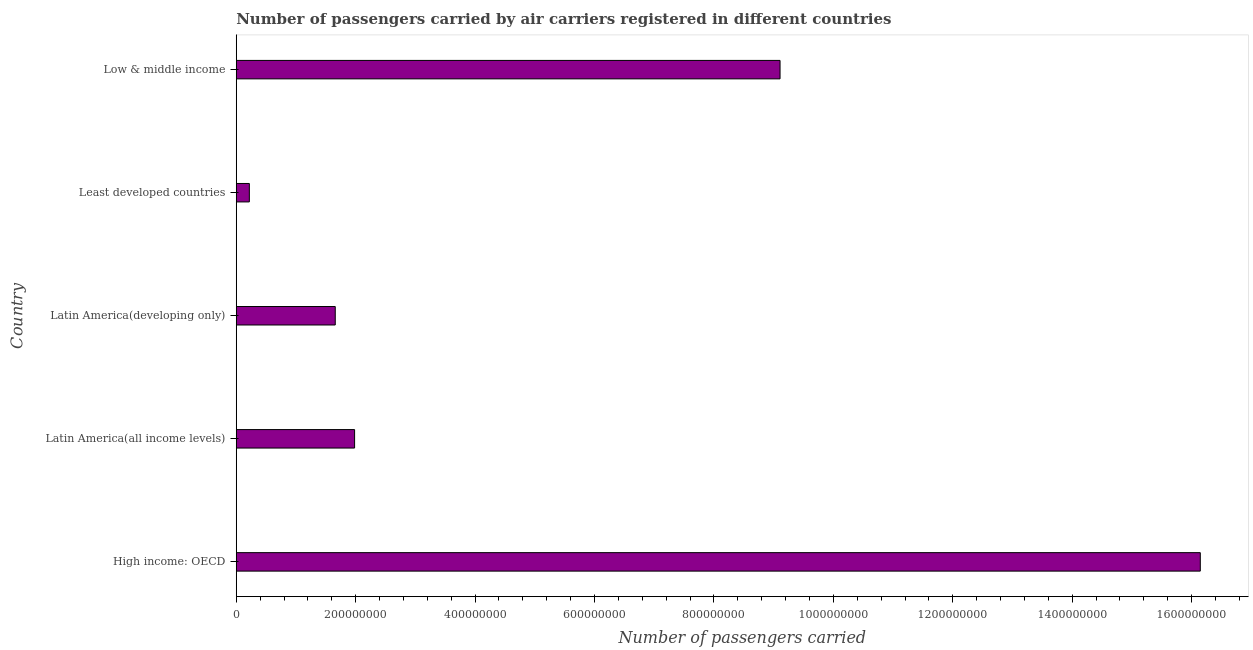Does the graph contain any zero values?
Offer a terse response. No. Does the graph contain grids?
Offer a very short reply. No. What is the title of the graph?
Provide a short and direct response. Number of passengers carried by air carriers registered in different countries. What is the label or title of the X-axis?
Make the answer very short. Number of passengers carried. What is the label or title of the Y-axis?
Offer a very short reply. Country. What is the number of passengers carried in High income: OECD?
Offer a terse response. 1.61e+09. Across all countries, what is the maximum number of passengers carried?
Ensure brevity in your answer.  1.61e+09. Across all countries, what is the minimum number of passengers carried?
Give a very brief answer. 2.19e+07. In which country was the number of passengers carried maximum?
Provide a short and direct response. High income: OECD. In which country was the number of passengers carried minimum?
Provide a short and direct response. Least developed countries. What is the sum of the number of passengers carried?
Ensure brevity in your answer.  2.91e+09. What is the difference between the number of passengers carried in Latin America(all income levels) and Least developed countries?
Give a very brief answer. 1.76e+08. What is the average number of passengers carried per country?
Your answer should be very brief. 5.82e+08. What is the median number of passengers carried?
Make the answer very short. 1.98e+08. In how many countries, is the number of passengers carried greater than 880000000 ?
Offer a very short reply. 2. What is the ratio of the number of passengers carried in Latin America(developing only) to that in Least developed countries?
Your answer should be compact. 7.56. Is the number of passengers carried in Latin America(all income levels) less than that in Low & middle income?
Offer a terse response. Yes. What is the difference between the highest and the second highest number of passengers carried?
Your answer should be compact. 7.04e+08. What is the difference between the highest and the lowest number of passengers carried?
Ensure brevity in your answer.  1.59e+09. How many bars are there?
Ensure brevity in your answer.  5. Are all the bars in the graph horizontal?
Your answer should be very brief. Yes. What is the difference between two consecutive major ticks on the X-axis?
Ensure brevity in your answer.  2.00e+08. Are the values on the major ticks of X-axis written in scientific E-notation?
Keep it short and to the point. No. What is the Number of passengers carried in High income: OECD?
Give a very brief answer. 1.61e+09. What is the Number of passengers carried of Latin America(all income levels)?
Offer a very short reply. 1.98e+08. What is the Number of passengers carried in Latin America(developing only)?
Keep it short and to the point. 1.66e+08. What is the Number of passengers carried of Least developed countries?
Your answer should be compact. 2.19e+07. What is the Number of passengers carried in Low & middle income?
Provide a succinct answer. 9.11e+08. What is the difference between the Number of passengers carried in High income: OECD and Latin America(all income levels)?
Ensure brevity in your answer.  1.42e+09. What is the difference between the Number of passengers carried in High income: OECD and Latin America(developing only)?
Offer a terse response. 1.45e+09. What is the difference between the Number of passengers carried in High income: OECD and Least developed countries?
Give a very brief answer. 1.59e+09. What is the difference between the Number of passengers carried in High income: OECD and Low & middle income?
Offer a terse response. 7.04e+08. What is the difference between the Number of passengers carried in Latin America(all income levels) and Latin America(developing only)?
Keep it short and to the point. 3.24e+07. What is the difference between the Number of passengers carried in Latin America(all income levels) and Least developed countries?
Make the answer very short. 1.76e+08. What is the difference between the Number of passengers carried in Latin America(all income levels) and Low & middle income?
Your answer should be compact. -7.13e+08. What is the difference between the Number of passengers carried in Latin America(developing only) and Least developed countries?
Your answer should be very brief. 1.44e+08. What is the difference between the Number of passengers carried in Latin America(developing only) and Low & middle income?
Your answer should be compact. -7.45e+08. What is the difference between the Number of passengers carried in Least developed countries and Low & middle income?
Provide a succinct answer. -8.89e+08. What is the ratio of the Number of passengers carried in High income: OECD to that in Latin America(all income levels)?
Provide a succinct answer. 8.15. What is the ratio of the Number of passengers carried in High income: OECD to that in Latin America(developing only)?
Offer a terse response. 9.74. What is the ratio of the Number of passengers carried in High income: OECD to that in Least developed countries?
Your answer should be very brief. 73.63. What is the ratio of the Number of passengers carried in High income: OECD to that in Low & middle income?
Keep it short and to the point. 1.77. What is the ratio of the Number of passengers carried in Latin America(all income levels) to that in Latin America(developing only)?
Your response must be concise. 1.2. What is the ratio of the Number of passengers carried in Latin America(all income levels) to that in Least developed countries?
Provide a short and direct response. 9.04. What is the ratio of the Number of passengers carried in Latin America(all income levels) to that in Low & middle income?
Offer a terse response. 0.22. What is the ratio of the Number of passengers carried in Latin America(developing only) to that in Least developed countries?
Provide a succinct answer. 7.56. What is the ratio of the Number of passengers carried in Latin America(developing only) to that in Low & middle income?
Make the answer very short. 0.18. What is the ratio of the Number of passengers carried in Least developed countries to that in Low & middle income?
Give a very brief answer. 0.02. 